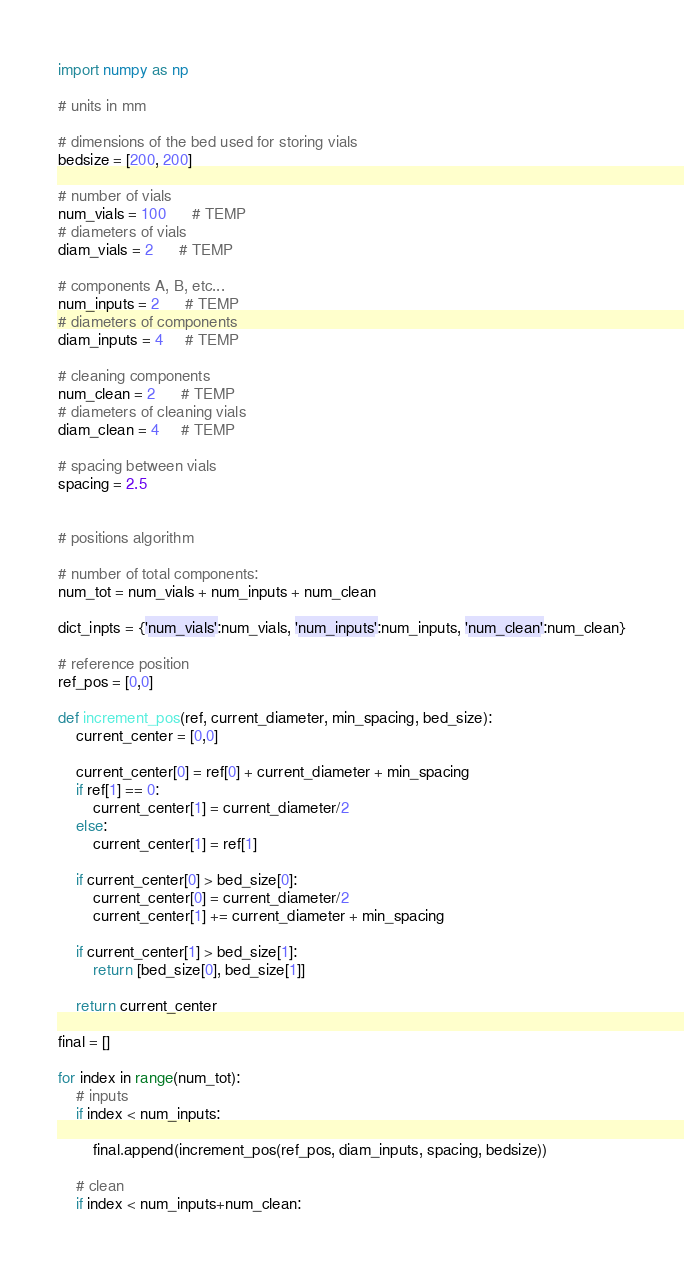<code> <loc_0><loc_0><loc_500><loc_500><_Python_>import numpy as np

# units in mm

# dimensions of the bed used for storing vials
bedsize = [200, 200]

# number of vials
num_vials = 100      # TEMP
# diameters of vials
diam_vials = 2      # TEMP

# components A, B, etc...
num_inputs = 2      # TEMP
# diameters of components
diam_inputs = 4     # TEMP

# cleaning components
num_clean = 2      # TEMP
# diameters of cleaning vials
diam_clean = 4     # TEMP

# spacing between vials
spacing = 2.5


# positions algorithm

# number of total components:
num_tot = num_vials + num_inputs + num_clean

dict_inpts = {'num_vials':num_vials, 'num_inputs':num_inputs, 'num_clean':num_clean}

# reference position
ref_pos = [0,0]

def increment_pos(ref, current_diameter, min_spacing, bed_size):
    current_center = [0,0]
    
    current_center[0] = ref[0] + current_diameter + min_spacing
    if ref[1] == 0:
        current_center[1] = current_diameter/2
    else:
        current_center[1] = ref[1]

    if current_center[0] > bed_size[0]:
        current_center[0] = current_diameter/2
        current_center[1] += current_diameter + min_spacing
    
    if current_center[1] > bed_size[1]:
        return [bed_size[0], bed_size[1]]
    
    return current_center

final = []

for index in range(num_tot):
    # inputs
    if index < num_inputs:

        final.append(increment_pos(ref_pos, diam_inputs, spacing, bedsize))

    # clean
    if index < num_inputs+num_clean:</code> 